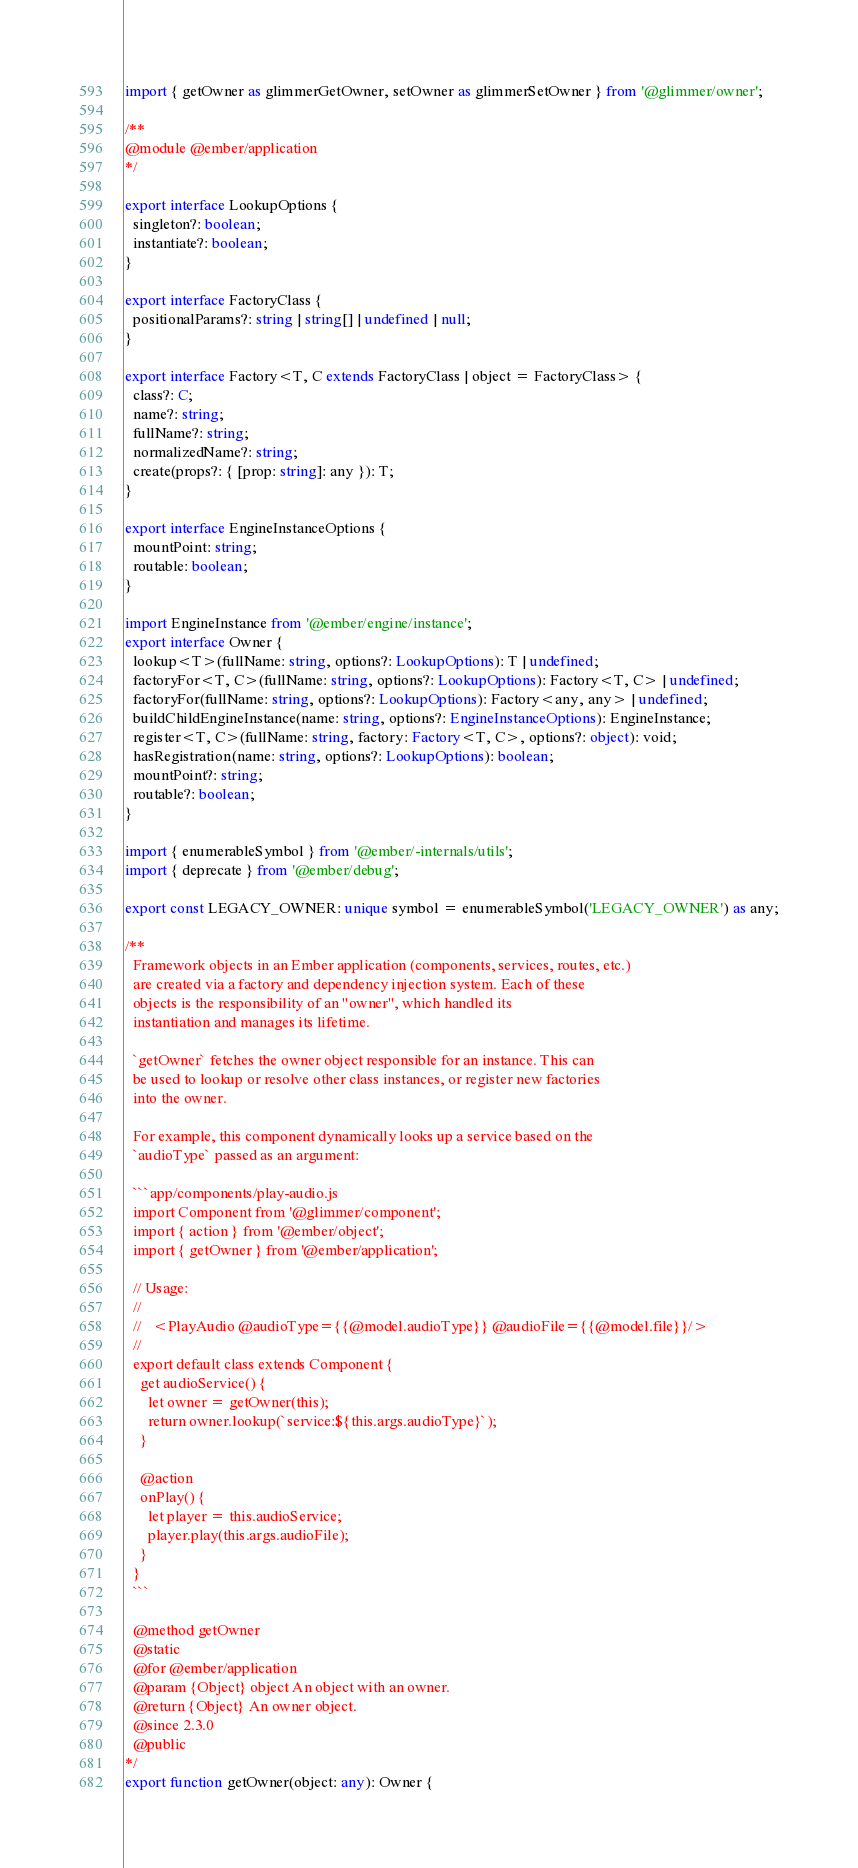<code> <loc_0><loc_0><loc_500><loc_500><_TypeScript_>import { getOwner as glimmerGetOwner, setOwner as glimmerSetOwner } from '@glimmer/owner';

/**
@module @ember/application
*/

export interface LookupOptions {
  singleton?: boolean;
  instantiate?: boolean;
}

export interface FactoryClass {
  positionalParams?: string | string[] | undefined | null;
}

export interface Factory<T, C extends FactoryClass | object = FactoryClass> {
  class?: C;
  name?: string;
  fullName?: string;
  normalizedName?: string;
  create(props?: { [prop: string]: any }): T;
}

export interface EngineInstanceOptions {
  mountPoint: string;
  routable: boolean;
}

import EngineInstance from '@ember/engine/instance';
export interface Owner {
  lookup<T>(fullName: string, options?: LookupOptions): T | undefined;
  factoryFor<T, C>(fullName: string, options?: LookupOptions): Factory<T, C> | undefined;
  factoryFor(fullName: string, options?: LookupOptions): Factory<any, any> | undefined;
  buildChildEngineInstance(name: string, options?: EngineInstanceOptions): EngineInstance;
  register<T, C>(fullName: string, factory: Factory<T, C>, options?: object): void;
  hasRegistration(name: string, options?: LookupOptions): boolean;
  mountPoint?: string;
  routable?: boolean;
}

import { enumerableSymbol } from '@ember/-internals/utils';
import { deprecate } from '@ember/debug';

export const LEGACY_OWNER: unique symbol = enumerableSymbol('LEGACY_OWNER') as any;

/**
  Framework objects in an Ember application (components, services, routes, etc.)
  are created via a factory and dependency injection system. Each of these
  objects is the responsibility of an "owner", which handled its
  instantiation and manages its lifetime.

  `getOwner` fetches the owner object responsible for an instance. This can
  be used to lookup or resolve other class instances, or register new factories
  into the owner.

  For example, this component dynamically looks up a service based on the
  `audioType` passed as an argument:

  ```app/components/play-audio.js
  import Component from '@glimmer/component';
  import { action } from '@ember/object';
  import { getOwner } from '@ember/application';

  // Usage:
  //
  //   <PlayAudio @audioType={{@model.audioType}} @audioFile={{@model.file}}/>
  //
  export default class extends Component {
    get audioService() {
      let owner = getOwner(this);
      return owner.lookup(`service:${this.args.audioType}`);
    }

    @action
    onPlay() {
      let player = this.audioService;
      player.play(this.args.audioFile);
    }
  }
  ```

  @method getOwner
  @static
  @for @ember/application
  @param {Object} object An object with an owner.
  @return {Object} An owner object.
  @since 2.3.0
  @public
*/
export function getOwner(object: any): Owner {</code> 